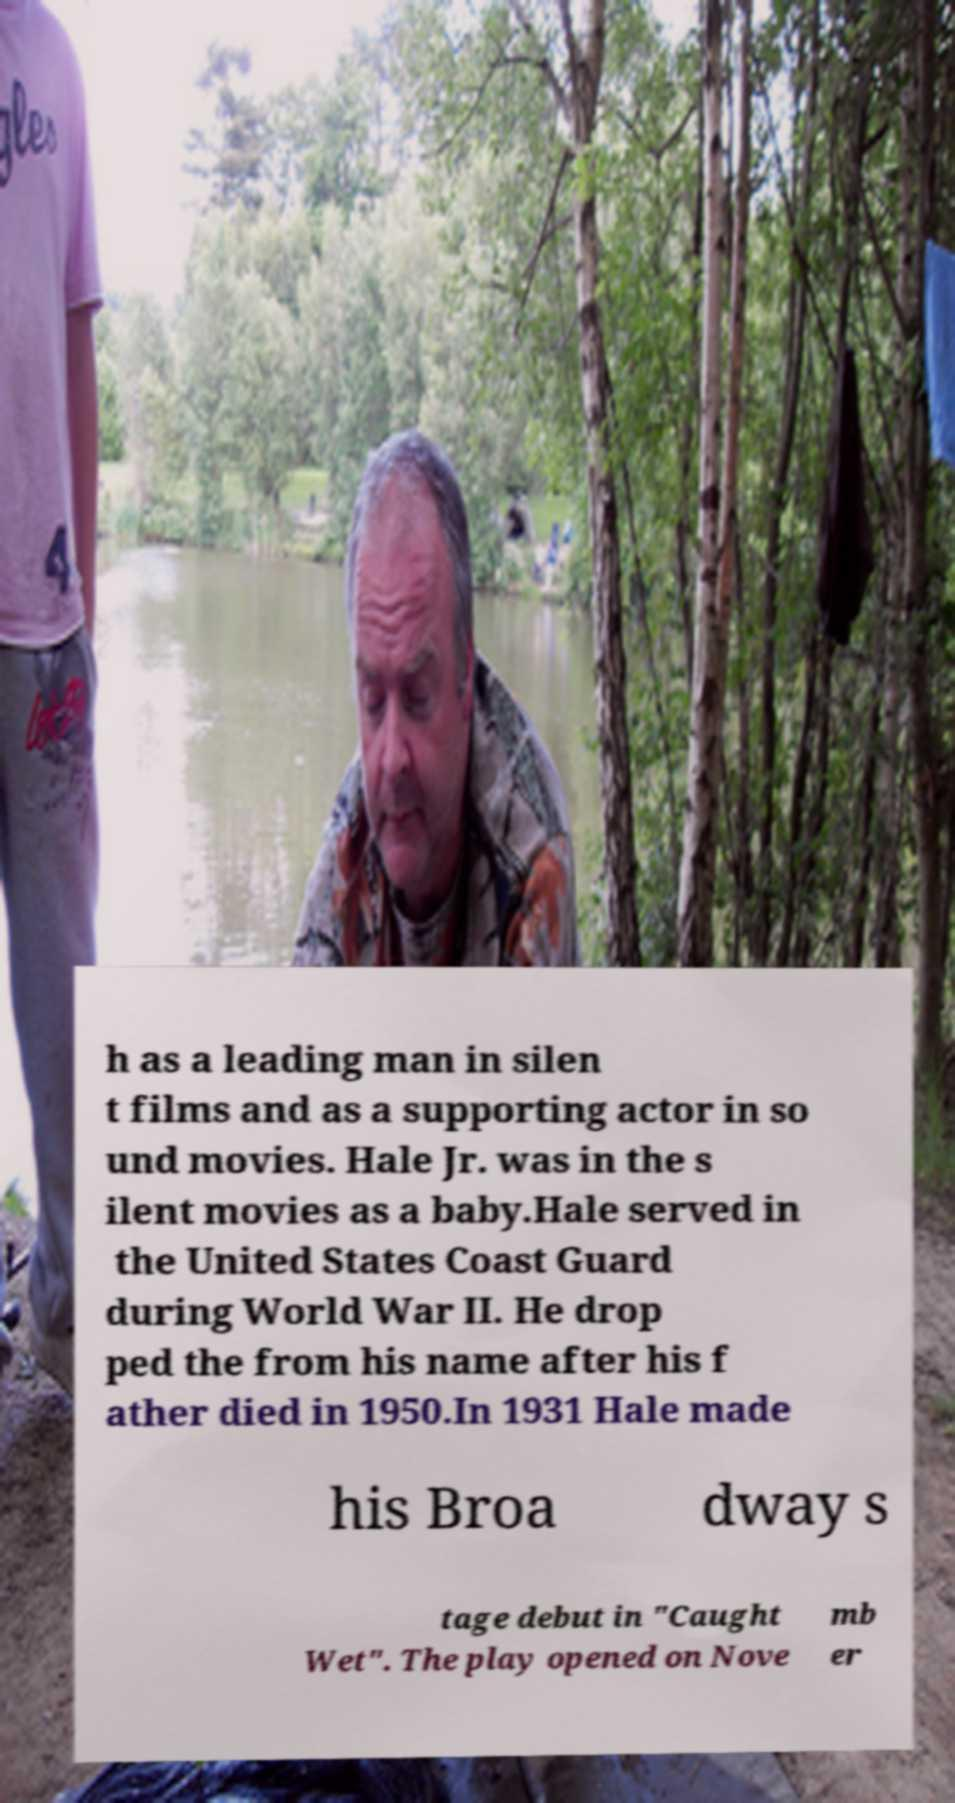I need the written content from this picture converted into text. Can you do that? h as a leading man in silen t films and as a supporting actor in so und movies. Hale Jr. was in the s ilent movies as a baby.Hale served in the United States Coast Guard during World War II. He drop ped the from his name after his f ather died in 1950.In 1931 Hale made his Broa dway s tage debut in "Caught Wet". The play opened on Nove mb er 